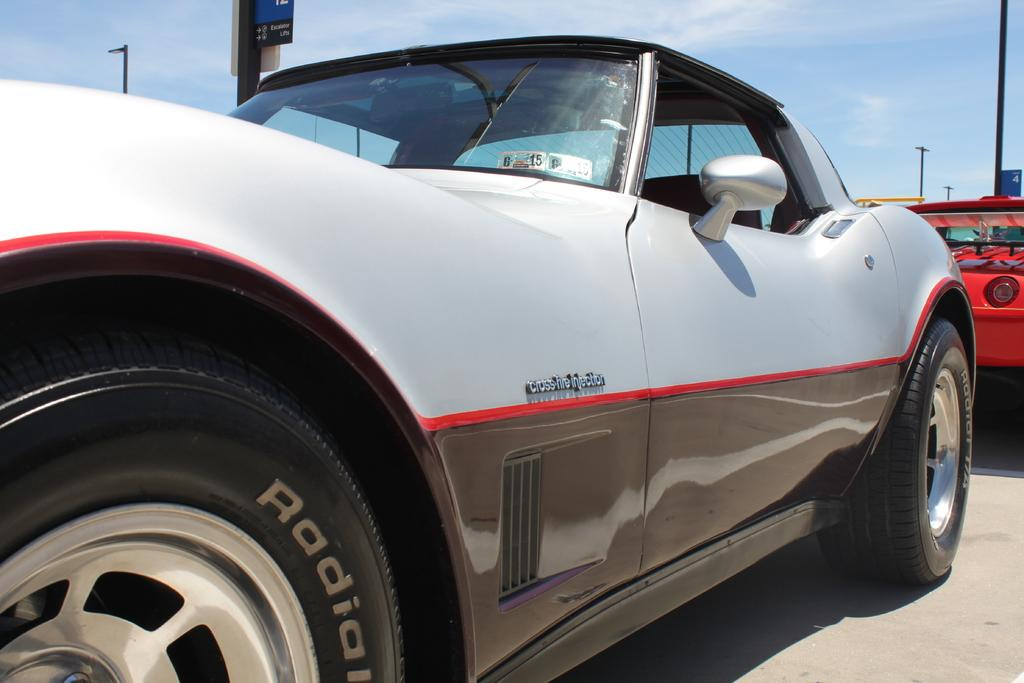What is the main subject of the image? The main subject of the image is a white color car. Where is the car located in the image? The car is parked on the road. What can be seen in the background of the image? There are poles and a red color car visible in the background. What part of the natural environment is visible in the image? The sky is visible in the image. How many snails can be seen crawling on the white color car in the image? There are no snails visible on the white color car in the image. What type of letters are written on the car's windshield in the image? There are no letters visible on the car's windshield in the image. 